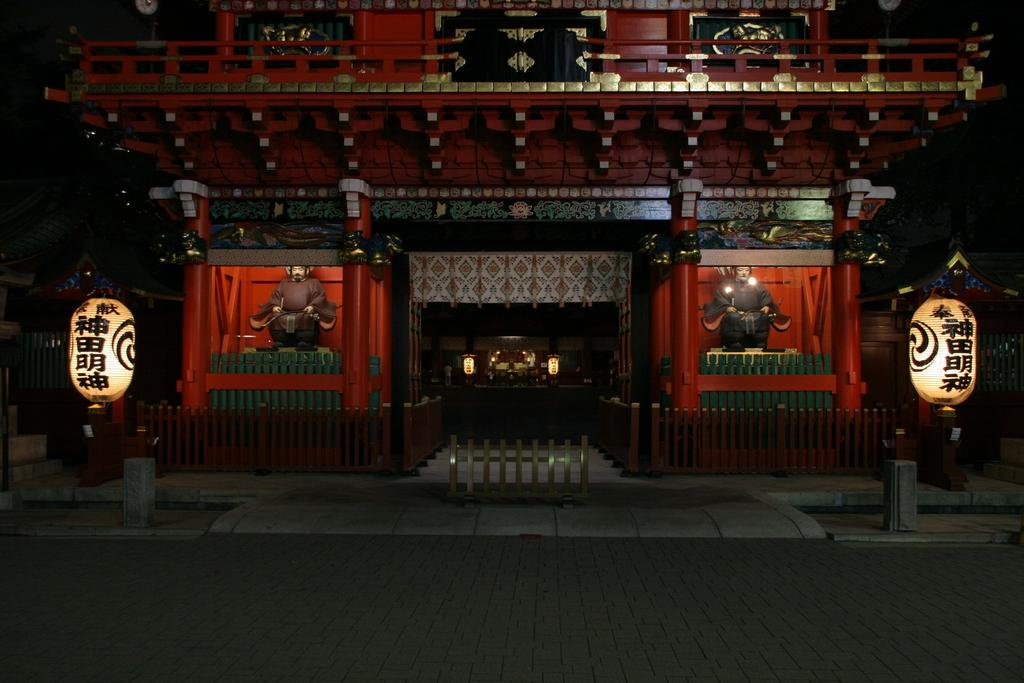What is the main feature of the image? There is a road in the image. What type of lighting is present in the image? Lanterns are present in the image. What type of structures can be seen in the image? Fences, poles, statues, and pillars are visible in the image. What can be inferred about the objects in the image? There are some objects in the image, but their specific nature is not clear. How would you describe the overall appearance of the image? The background of the image is dark. How many brothers are playing in the field in the image? There are no brothers or fields present in the image. What type of scale is used to weigh the objects in the image? There is no scale present in the image, and therefore no objects are being weighed. 